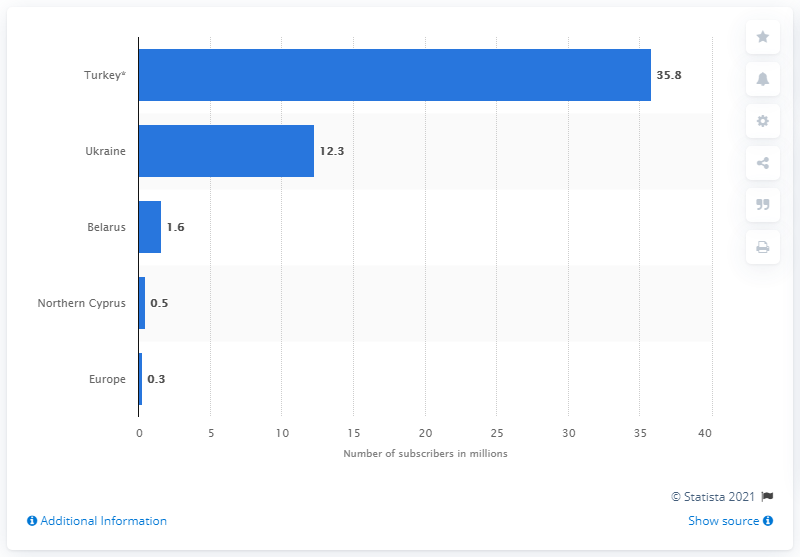Point out several critical features in this image. In the first quarter of 2017, Turkey had approximately 35.8 million mobile subscribers. 